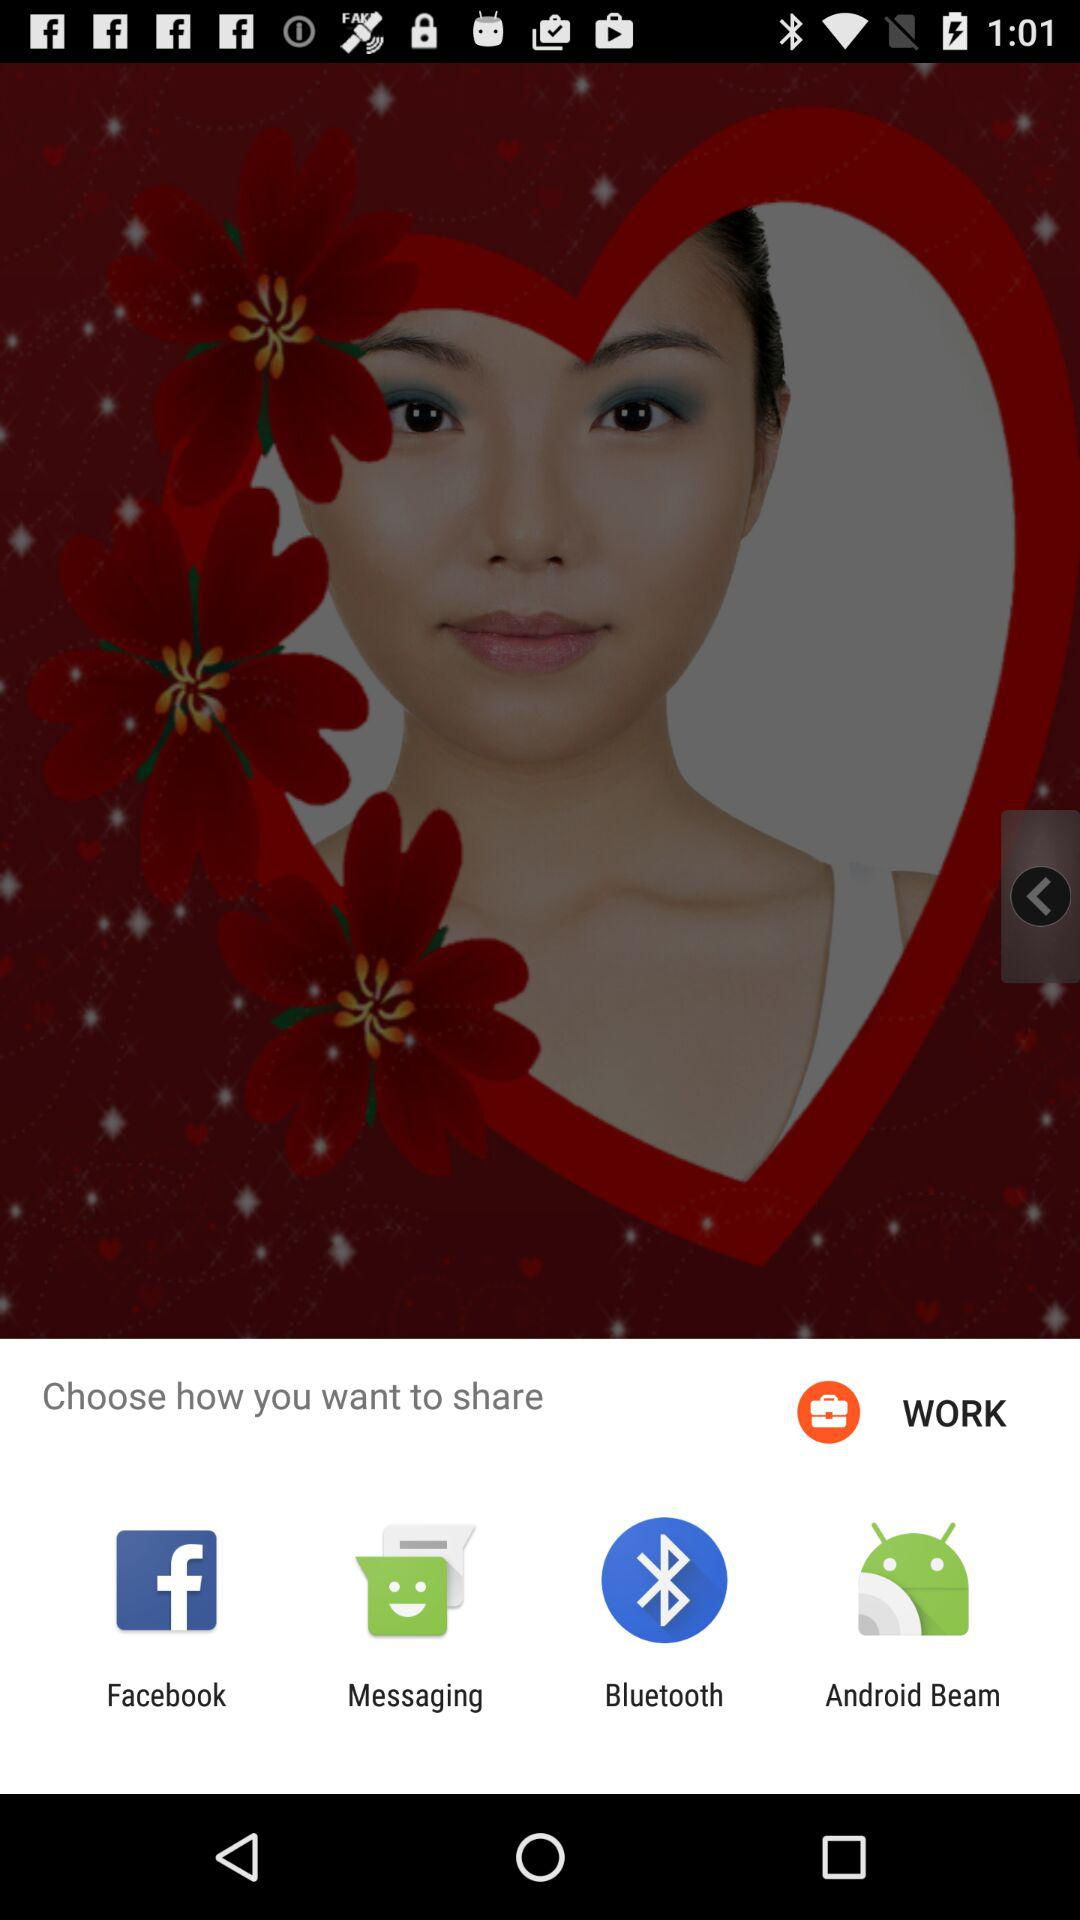Through which applications can content be shared? Content can be shared through "Facebook", "Messaging", "Bluetooth" and "Android Beam". 